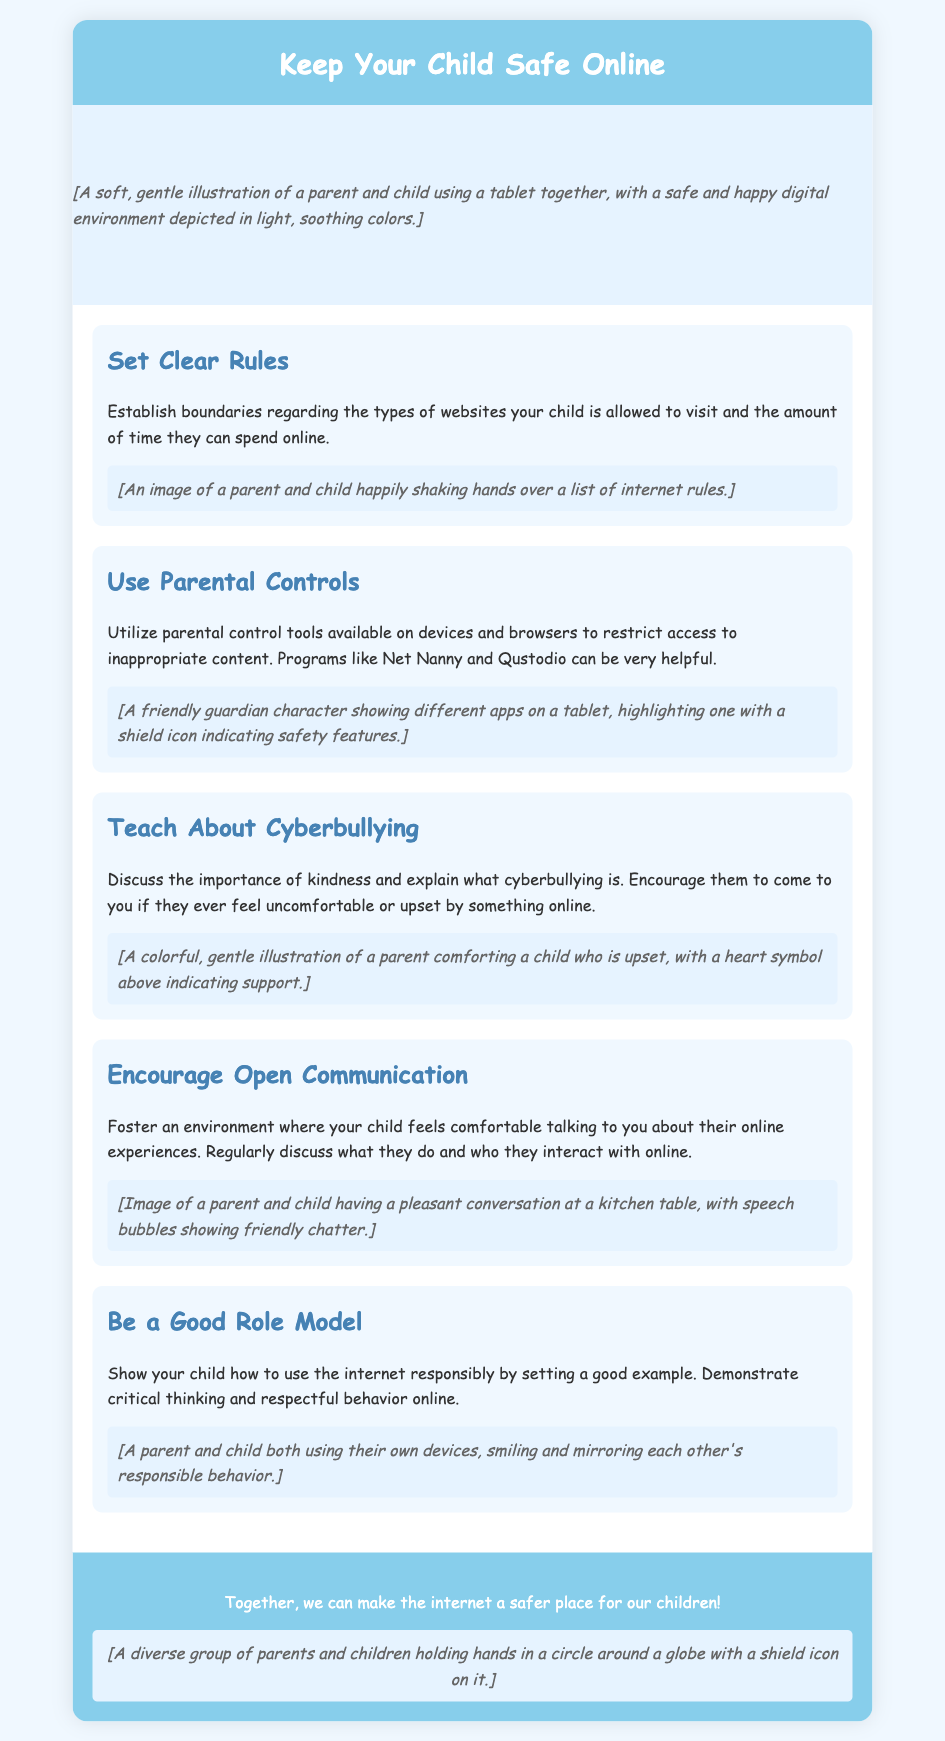What is the title of the card? The title prominently displayed at the top of the card indicates the main topic of concern for parents.
Answer: Keep Your Child Safe Online What is one tool mentioned for parental controls? The document provides examples of specific programs that can help parents monitor online activity, one of which is noted as helpful.
Answer: Net Nanny How many sections are included in the card? The structure of the card can be quantified by counting the main topics addressed, which are divided into distinct sections.
Answer: Five What color is the card header? The color used in the card header contributes to the overall design and conveys a sense of calmness and safety.
Answer: Light blue What is the importance of communication emphasized in the card? The card highlights a key point regarding the relationship between a parent and child regarding sharing online experiences and fostering trust.
Answer: Open communication How does the card suggest parents should model behavior? This portion of the document connects the idea of parental guidance to personal conduct, urging parents to show responsible usage.
Answer: Be a good role model 